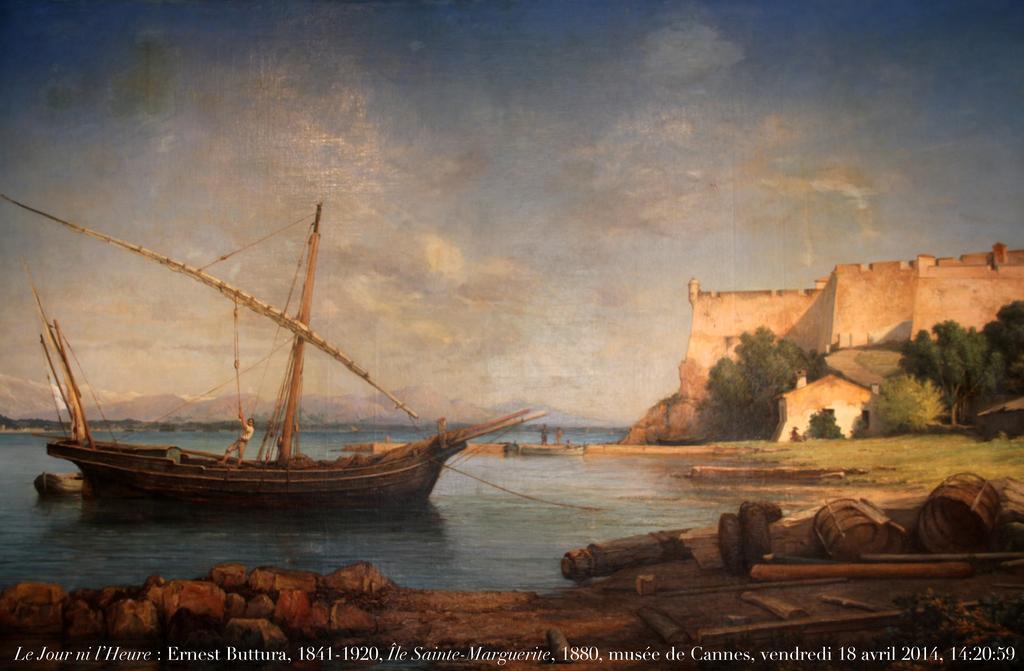Please provide a concise description of this image. I see this is an animated picture and I see a boat over here on which there is a person and I see the water and I see the wooden things on this ground. In the background I see the trees, grass, fort and the sky and I see 2 persons over here and I see the watermark over here. 